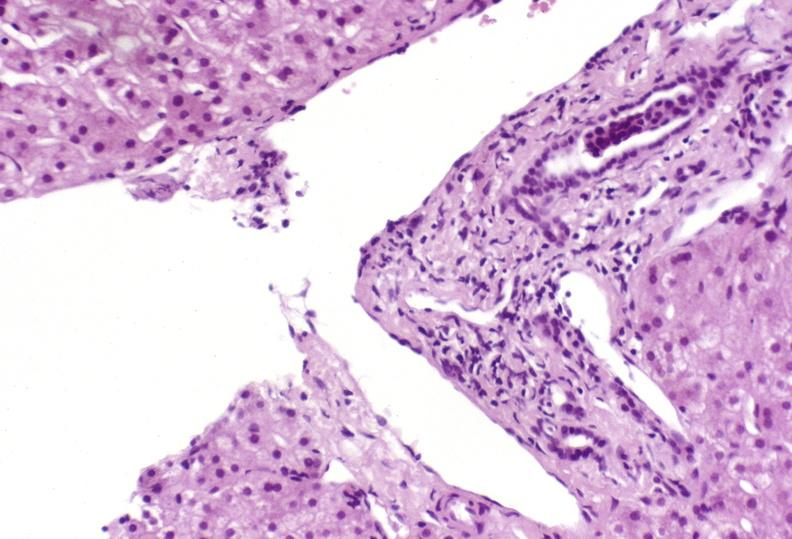s anencephaly present?
Answer the question using a single word or phrase. No 